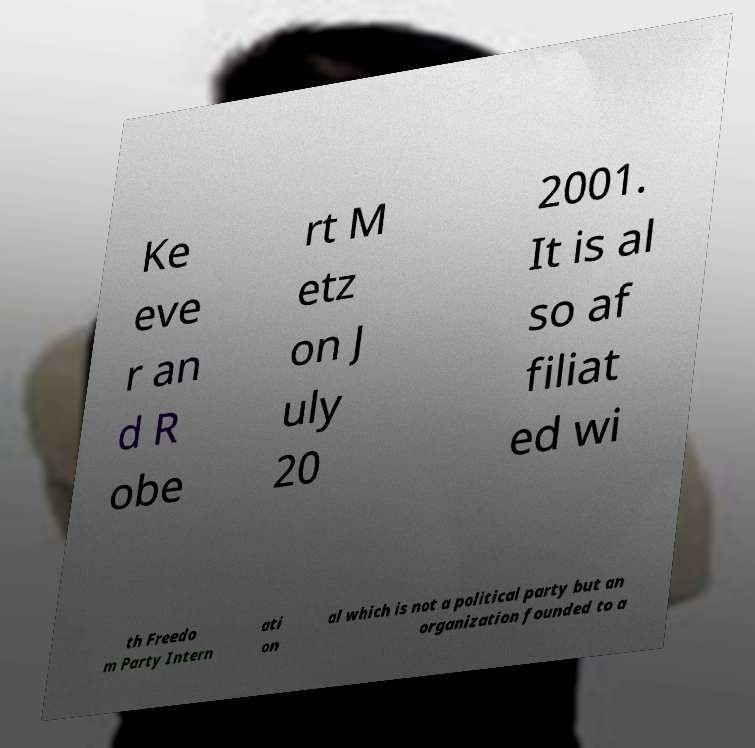Can you accurately transcribe the text from the provided image for me? Ke eve r an d R obe rt M etz on J uly 20 2001. It is al so af filiat ed wi th Freedo m Party Intern ati on al which is not a political party but an organization founded to a 